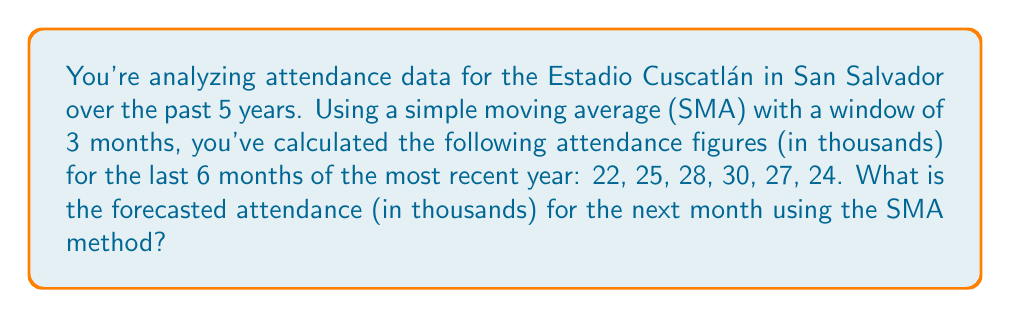Solve this math problem. Let's approach this step-by-step:

1) The Simple Moving Average (SMA) is calculated by taking the arithmetic mean of a given set of values over a specified period. In this case, we're using a 3-month window.

2) To forecast the next month's attendance, we'll use the SMA of the last 3 months in our data set.

3) The last 3 months' attendance figures are: 30, 27, and 24 (in thousands).

4) The formula for SMA is:

   $$SMA = \frac{\sum_{i=1}^{n} x_i}{n}$$

   Where $x_i$ are the individual values and $n$ is the number of periods.

5) Plugging in our values:

   $$SMA = \frac{30 + 27 + 24}{3}$$

6) Calculating:

   $$SMA = \frac{81}{3} = 27$$

Therefore, the forecasted attendance for the next month, based on the SMA method, is 27,000.
Answer: 27 